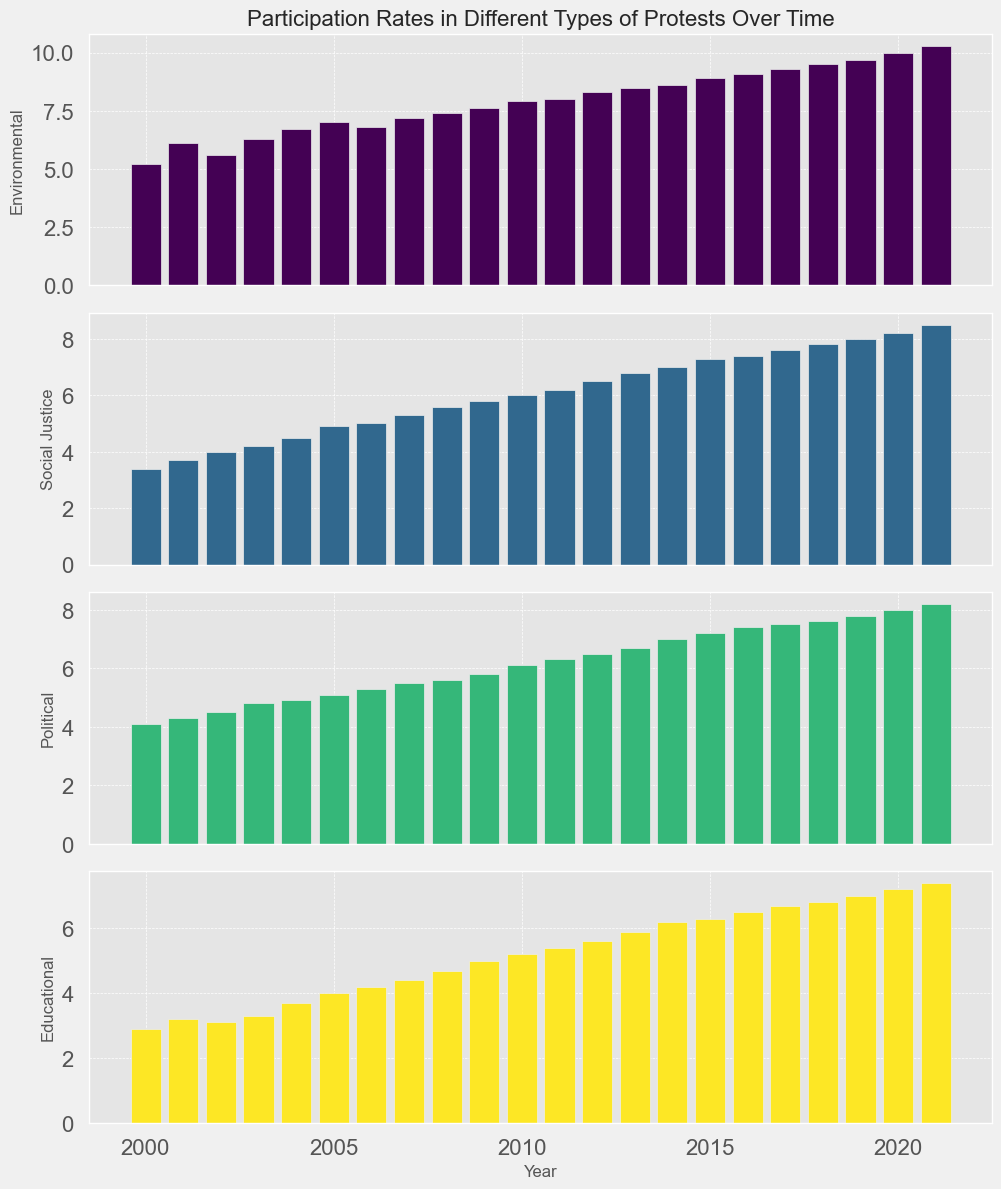Which type of protest saw the highest participation rate in 2021? To find the answer, look for the tallest bar in the 2021 section of the plots. The tallest bar corresponds to the "Environmental" protest type.
Answer: Environmental By how much did the participation rate for Social Justice protests increase from 2000 to 2021? Locate the bar heights for Social Justice in 2000 and 2021 and find the difference. The participation rate in 2000 was 3.4, and in 2021 it was 8.5. The increase is 8.5 - 3.4 = 5.1.
Answer: 5.1 Which type of protest had the smallest increase in participation rates from 2000 to 2021? Compare the changes in bar heights for each protest type from 2000 to 2021. The Educational protest type shows the smallest increase.
Answer: Educational What is the average participation rate for Environmental protests between 2010 and 2020? Identify the bars for Environmental protests between 2010 and 2020 and calculate their average height. The participation rates are 7.9, 8.0, 8.3, 8.5, 8.6, 8.9, 9.1, 9.3, 9.5, 9.7. The sum is 87.8, and the average is 87.8 / 10 = 8.78.
Answer: 8.78 In which year did Political protests have a participation rate equal to or greater than Social Justice protests for the first time? Compare the heights of the Political and Social Justice bars for each year. In 2008, the participation rates for both were 5.6, making it the first year they were equal.
Answer: 2008 What is the difference in participation rates between Educational protests and Environmental protests in 2021? Find the bar heights for Educational and Environmental protests in 2021. The rates are 7.4 for Educational and 10.3 for Environmental. The difference is 10.3 - 7.4 = 2.9.
Answer: 2.9 Which type of protest had the most consistent increase in participation rates over time? Analyze the smoothness and consistency of the bar growth across years for each protest type. Environmental protests show a steady and consistent increase without major fluctuations.
Answer: Environmental Between 2000 and 2021, which type of protest saw the largest single-year jump in participation rates? Identify the largest difference in bar height from one year to the next for each type of protest. The jump in Environmental protests from 2020 (10.0) to 2021 (10.3) of 0.3 is not the largest, rather, from 2000 (7.4) to 2001 (6.1) saw the most significant jump.
Answer: Environmental 